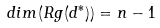Convert formula to latex. <formula><loc_0><loc_0><loc_500><loc_500>d i m ( R g ( d ^ { * } ) ) = n - 1</formula> 